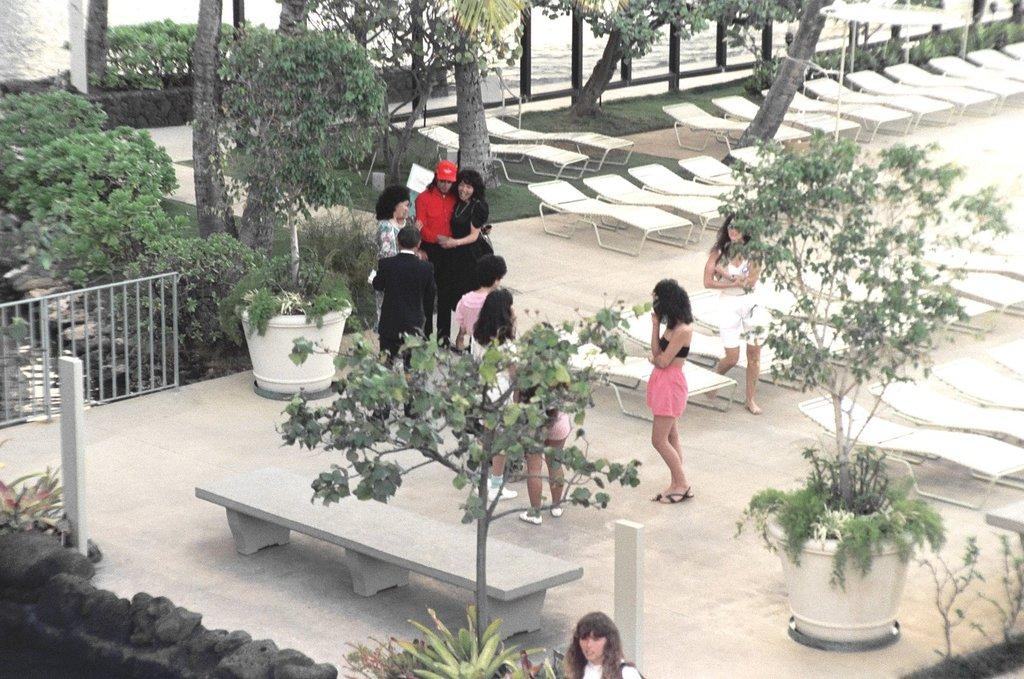Who or what is present in the image? There are people in the image. What type of seating is visible in the image? There is a bench and chairs on the ground in the image. Are there any plants in the image? Yes, there are houseplants in the image. What can be seen in the background of the image? There are trees visible in the background of the image. What type of account is being discussed by the people in the image? There is no indication of any account being discussed in the image; the conversation focuses on the visible objects and elements. 